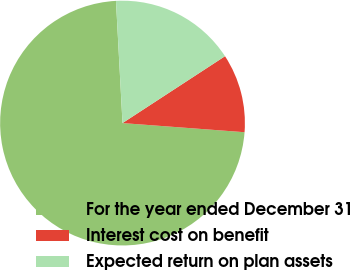Convert chart. <chart><loc_0><loc_0><loc_500><loc_500><pie_chart><fcel>For the year ended December 31<fcel>Interest cost on benefit<fcel>Expected return on plan assets<nl><fcel>72.96%<fcel>10.39%<fcel>16.65%<nl></chart> 